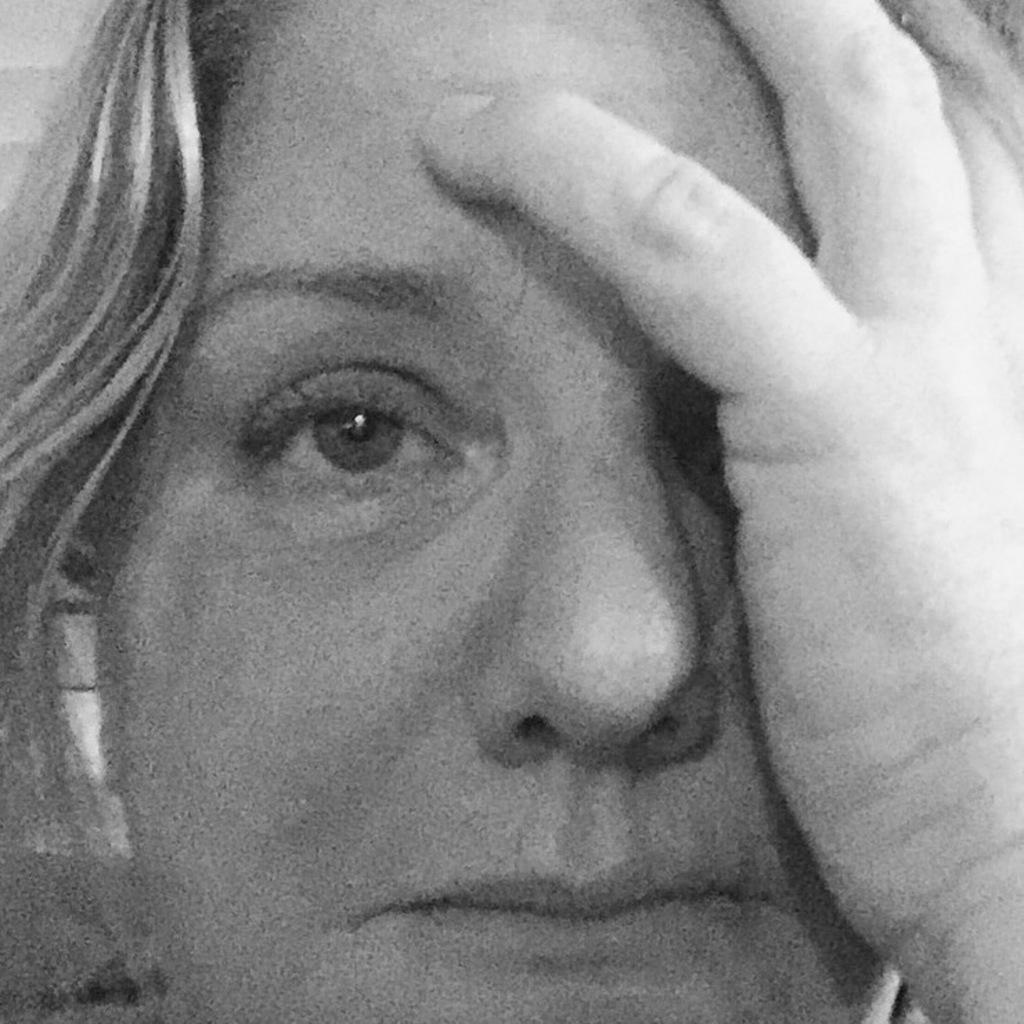How would you summarize this image in a sentence or two? In this picture I can see a woman. 